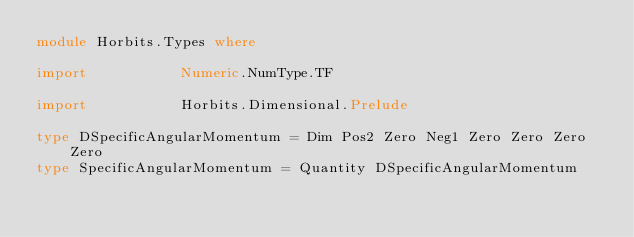<code> <loc_0><loc_0><loc_500><loc_500><_Haskell_>module Horbits.Types where

import           Numeric.NumType.TF

import           Horbits.Dimensional.Prelude

type DSpecificAngularMomentum = Dim Pos2 Zero Neg1 Zero Zero Zero Zero
type SpecificAngularMomentum = Quantity DSpecificAngularMomentum

</code> 